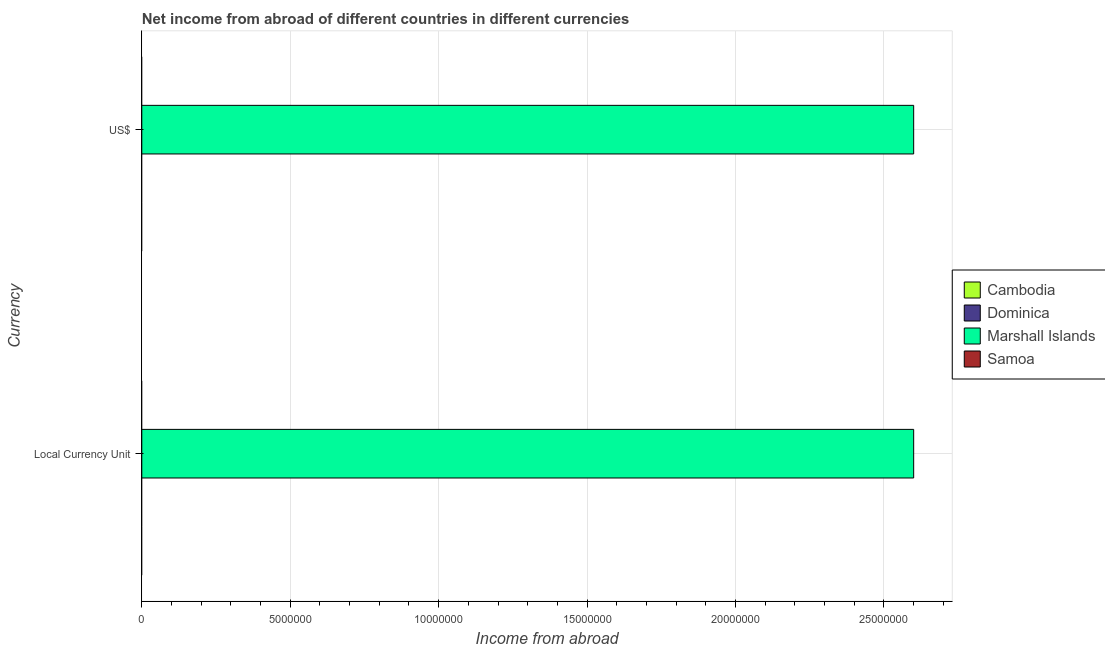What is the label of the 2nd group of bars from the top?
Your answer should be very brief. Local Currency Unit. What is the income from abroad in constant 2005 us$ in Cambodia?
Keep it short and to the point. 0. Across all countries, what is the maximum income from abroad in us$?
Offer a terse response. 2.60e+07. In which country was the income from abroad in constant 2005 us$ maximum?
Your answer should be very brief. Marshall Islands. What is the total income from abroad in us$ in the graph?
Your answer should be compact. 2.60e+07. What is the difference between the income from abroad in constant 2005 us$ in Cambodia and the income from abroad in us$ in Dominica?
Provide a short and direct response. 0. What is the average income from abroad in us$ per country?
Offer a very short reply. 6.50e+06. In how many countries, is the income from abroad in constant 2005 us$ greater than 2000000 units?
Provide a succinct answer. 1. How many countries are there in the graph?
Offer a very short reply. 4. Are the values on the major ticks of X-axis written in scientific E-notation?
Provide a short and direct response. No. Where does the legend appear in the graph?
Your answer should be very brief. Center right. How many legend labels are there?
Offer a terse response. 4. What is the title of the graph?
Keep it short and to the point. Net income from abroad of different countries in different currencies. Does "Cambodia" appear as one of the legend labels in the graph?
Give a very brief answer. Yes. What is the label or title of the X-axis?
Make the answer very short. Income from abroad. What is the label or title of the Y-axis?
Your response must be concise. Currency. What is the Income from abroad in Cambodia in Local Currency Unit?
Offer a very short reply. 0. What is the Income from abroad in Marshall Islands in Local Currency Unit?
Provide a short and direct response. 2.60e+07. What is the Income from abroad of Cambodia in US$?
Give a very brief answer. 0. What is the Income from abroad of Marshall Islands in US$?
Your answer should be compact. 2.60e+07. Across all Currency, what is the maximum Income from abroad in Marshall Islands?
Offer a terse response. 2.60e+07. Across all Currency, what is the minimum Income from abroad of Marshall Islands?
Keep it short and to the point. 2.60e+07. What is the total Income from abroad in Cambodia in the graph?
Ensure brevity in your answer.  0. What is the total Income from abroad of Dominica in the graph?
Offer a very short reply. 0. What is the total Income from abroad in Marshall Islands in the graph?
Give a very brief answer. 5.20e+07. What is the total Income from abroad in Samoa in the graph?
Make the answer very short. 0. What is the average Income from abroad in Cambodia per Currency?
Provide a short and direct response. 0. What is the average Income from abroad in Marshall Islands per Currency?
Your answer should be very brief. 2.60e+07. What is the average Income from abroad of Samoa per Currency?
Provide a short and direct response. 0. What is the ratio of the Income from abroad in Marshall Islands in Local Currency Unit to that in US$?
Provide a short and direct response. 1. What is the difference between the highest and the lowest Income from abroad in Marshall Islands?
Ensure brevity in your answer.  0. 